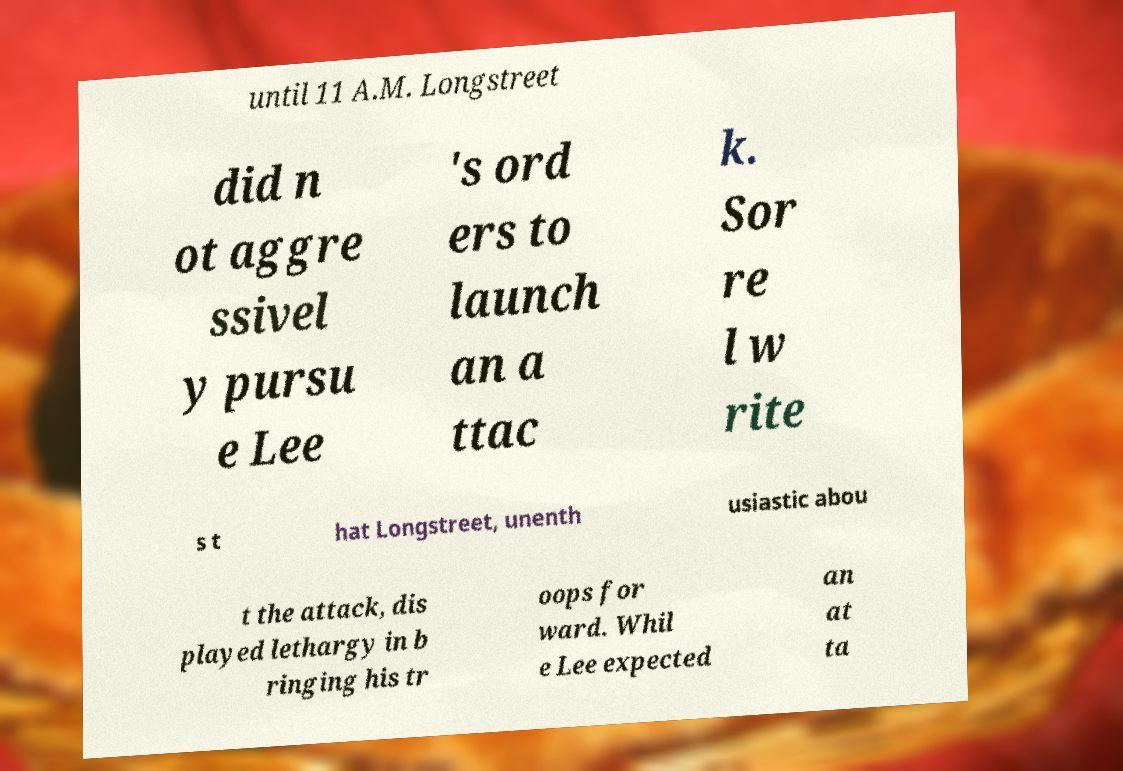Please identify and transcribe the text found in this image. until 11 A.M. Longstreet did n ot aggre ssivel y pursu e Lee 's ord ers to launch an a ttac k. Sor re l w rite s t hat Longstreet, unenth usiastic abou t the attack, dis played lethargy in b ringing his tr oops for ward. Whil e Lee expected an at ta 